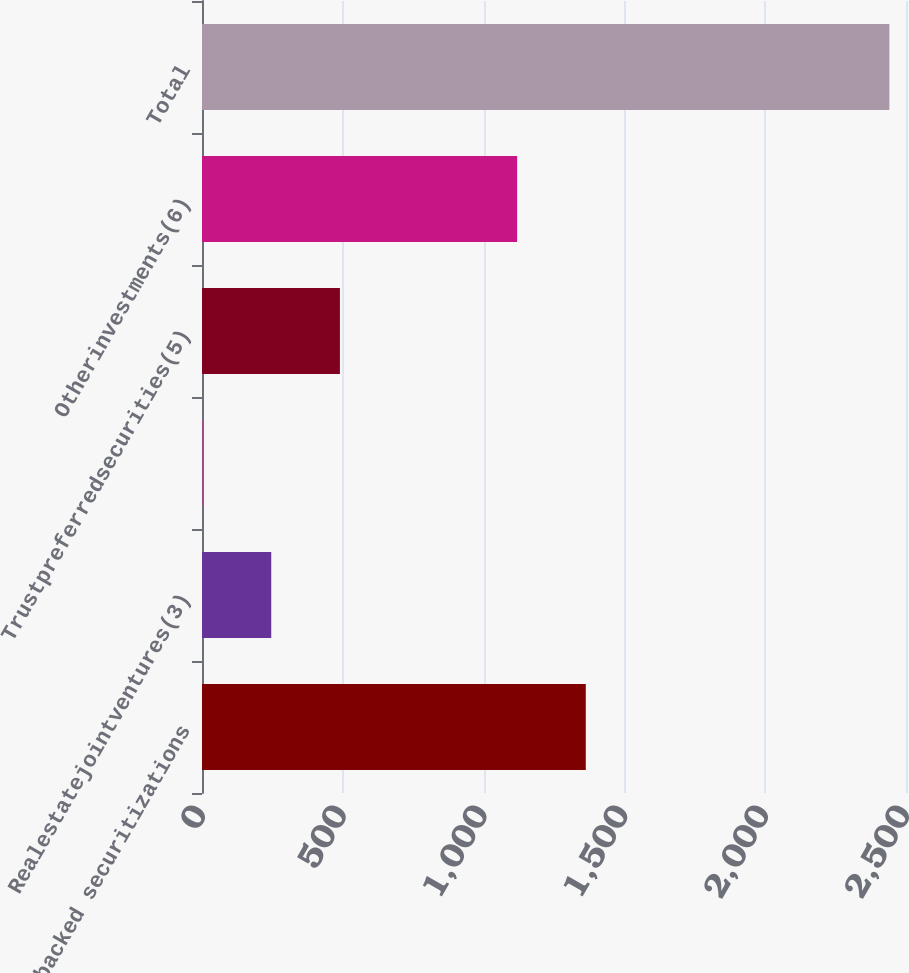Convert chart. <chart><loc_0><loc_0><loc_500><loc_500><bar_chart><fcel>Asset-backed securitizations<fcel>Realestatejointventures(3)<fcel>Unnamed: 2<fcel>Trustpreferredsecurities(5)<fcel>Otherinvestments(6)<fcel>Total<nl><fcel>1362.9<fcel>245.9<fcel>2<fcel>489.8<fcel>1119<fcel>2441<nl></chart> 